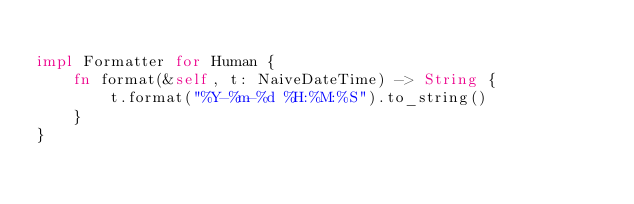<code> <loc_0><loc_0><loc_500><loc_500><_Rust_>
impl Formatter for Human {
    fn format(&self, t: NaiveDateTime) -> String {
        t.format("%Y-%m-%d %H:%M:%S").to_string()
    }
}
</code> 